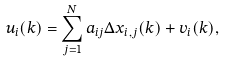<formula> <loc_0><loc_0><loc_500><loc_500>u _ { i } ( k ) = \sum _ { j = 1 } ^ { N } a _ { i j } \Delta x _ { i , j } ( k ) + v _ { i } ( k ) ,</formula> 